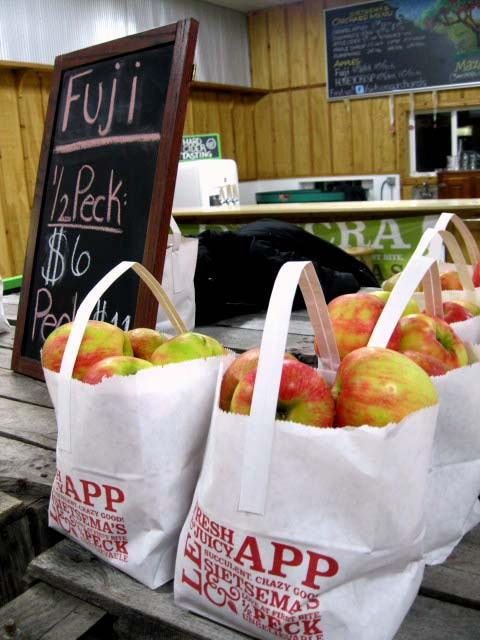What type of apples are being sold? The apples being sold are Fuji apples, as indicated by the signage visible in the image. 